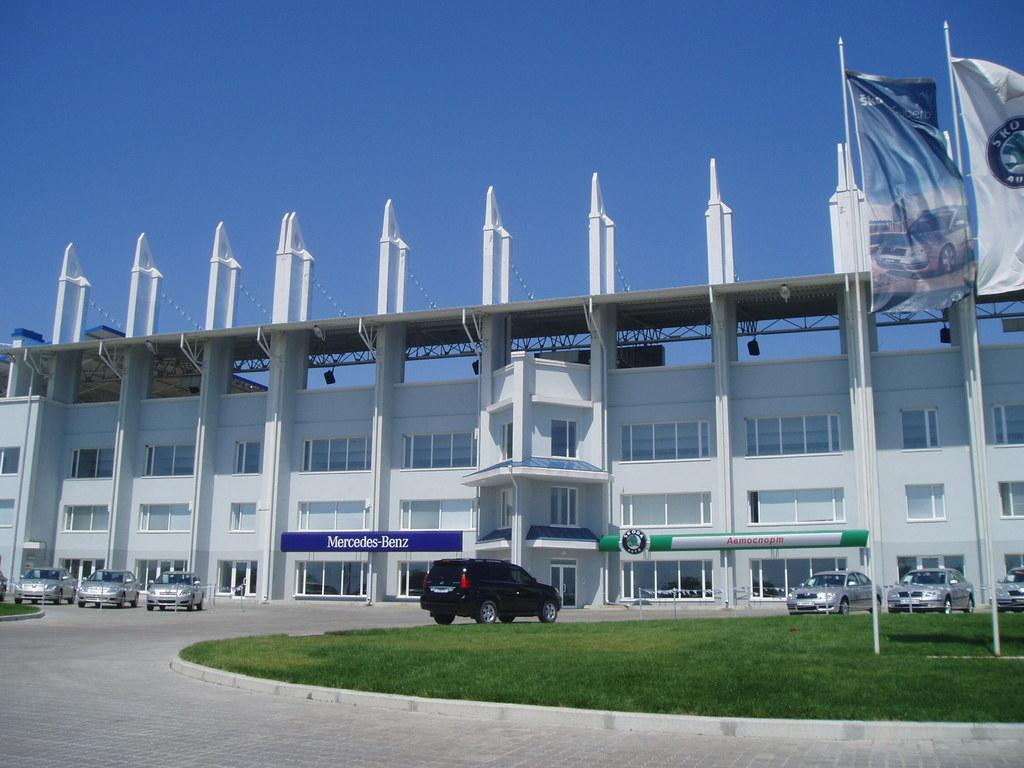What type of structure is visible in the image? There is a building in the image. What is in front of the building? There are many cars in front of the building. What type of landscape is visible in the image? There is a grassland in the image. What decorations can be seen in the image? There are flags in the image. What is the condition of the sky in the image? The sky is clear in the image. How many wings can be seen on the building in the image? There are no wings visible on the building in the image. What type of health advice is being given in the image? There is no health advice or any indication of health-related information in the image. 